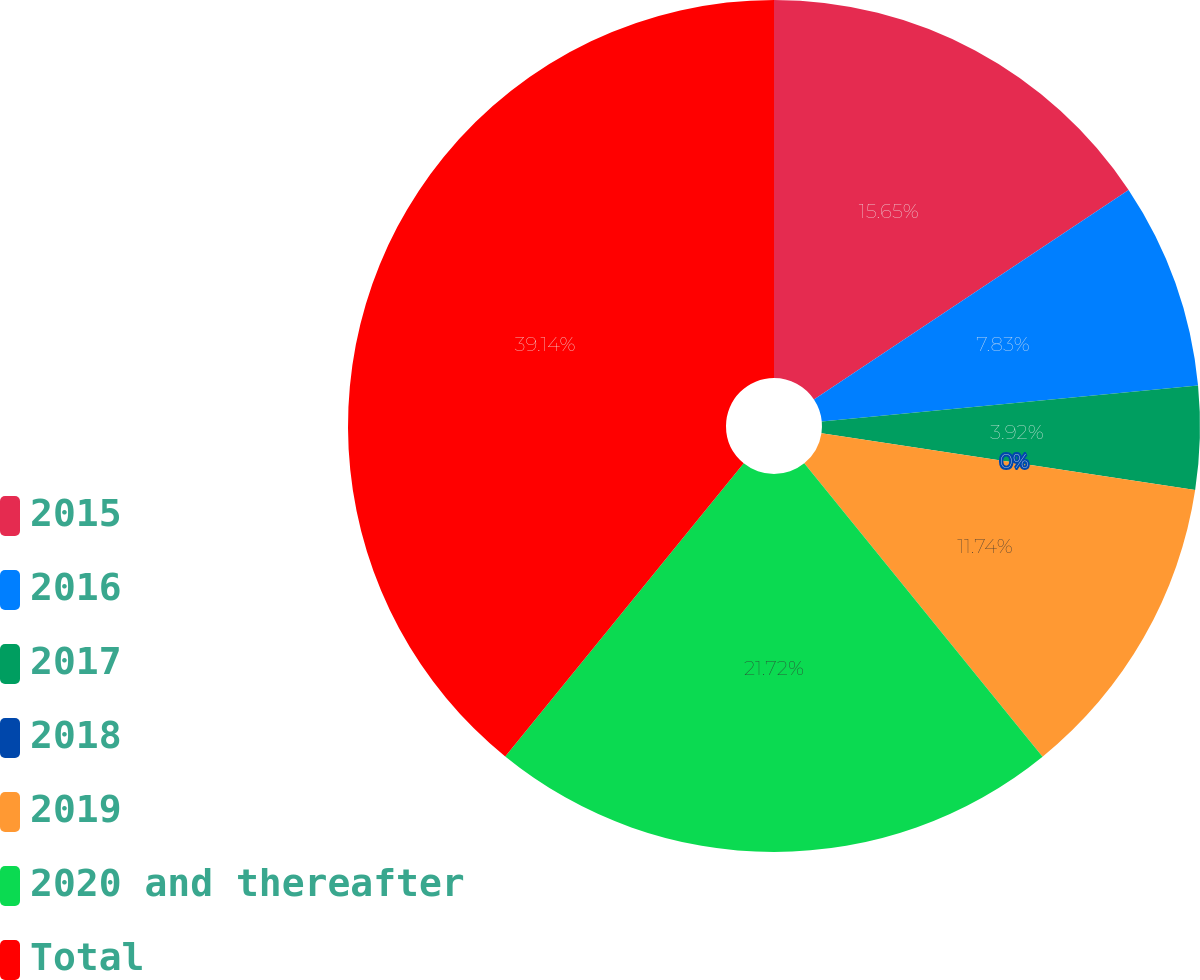Convert chart. <chart><loc_0><loc_0><loc_500><loc_500><pie_chart><fcel>2015<fcel>2016<fcel>2017<fcel>2018<fcel>2019<fcel>2020 and thereafter<fcel>Total<nl><fcel>15.65%<fcel>7.83%<fcel>3.92%<fcel>0.0%<fcel>11.74%<fcel>21.72%<fcel>39.13%<nl></chart> 